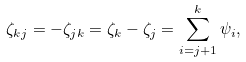<formula> <loc_0><loc_0><loc_500><loc_500>\zeta _ { k j } = - \zeta _ { j k } = \zeta _ { k } - \zeta _ { j } = \sum _ { i = j + 1 } ^ { k } \psi _ { i } ,</formula> 